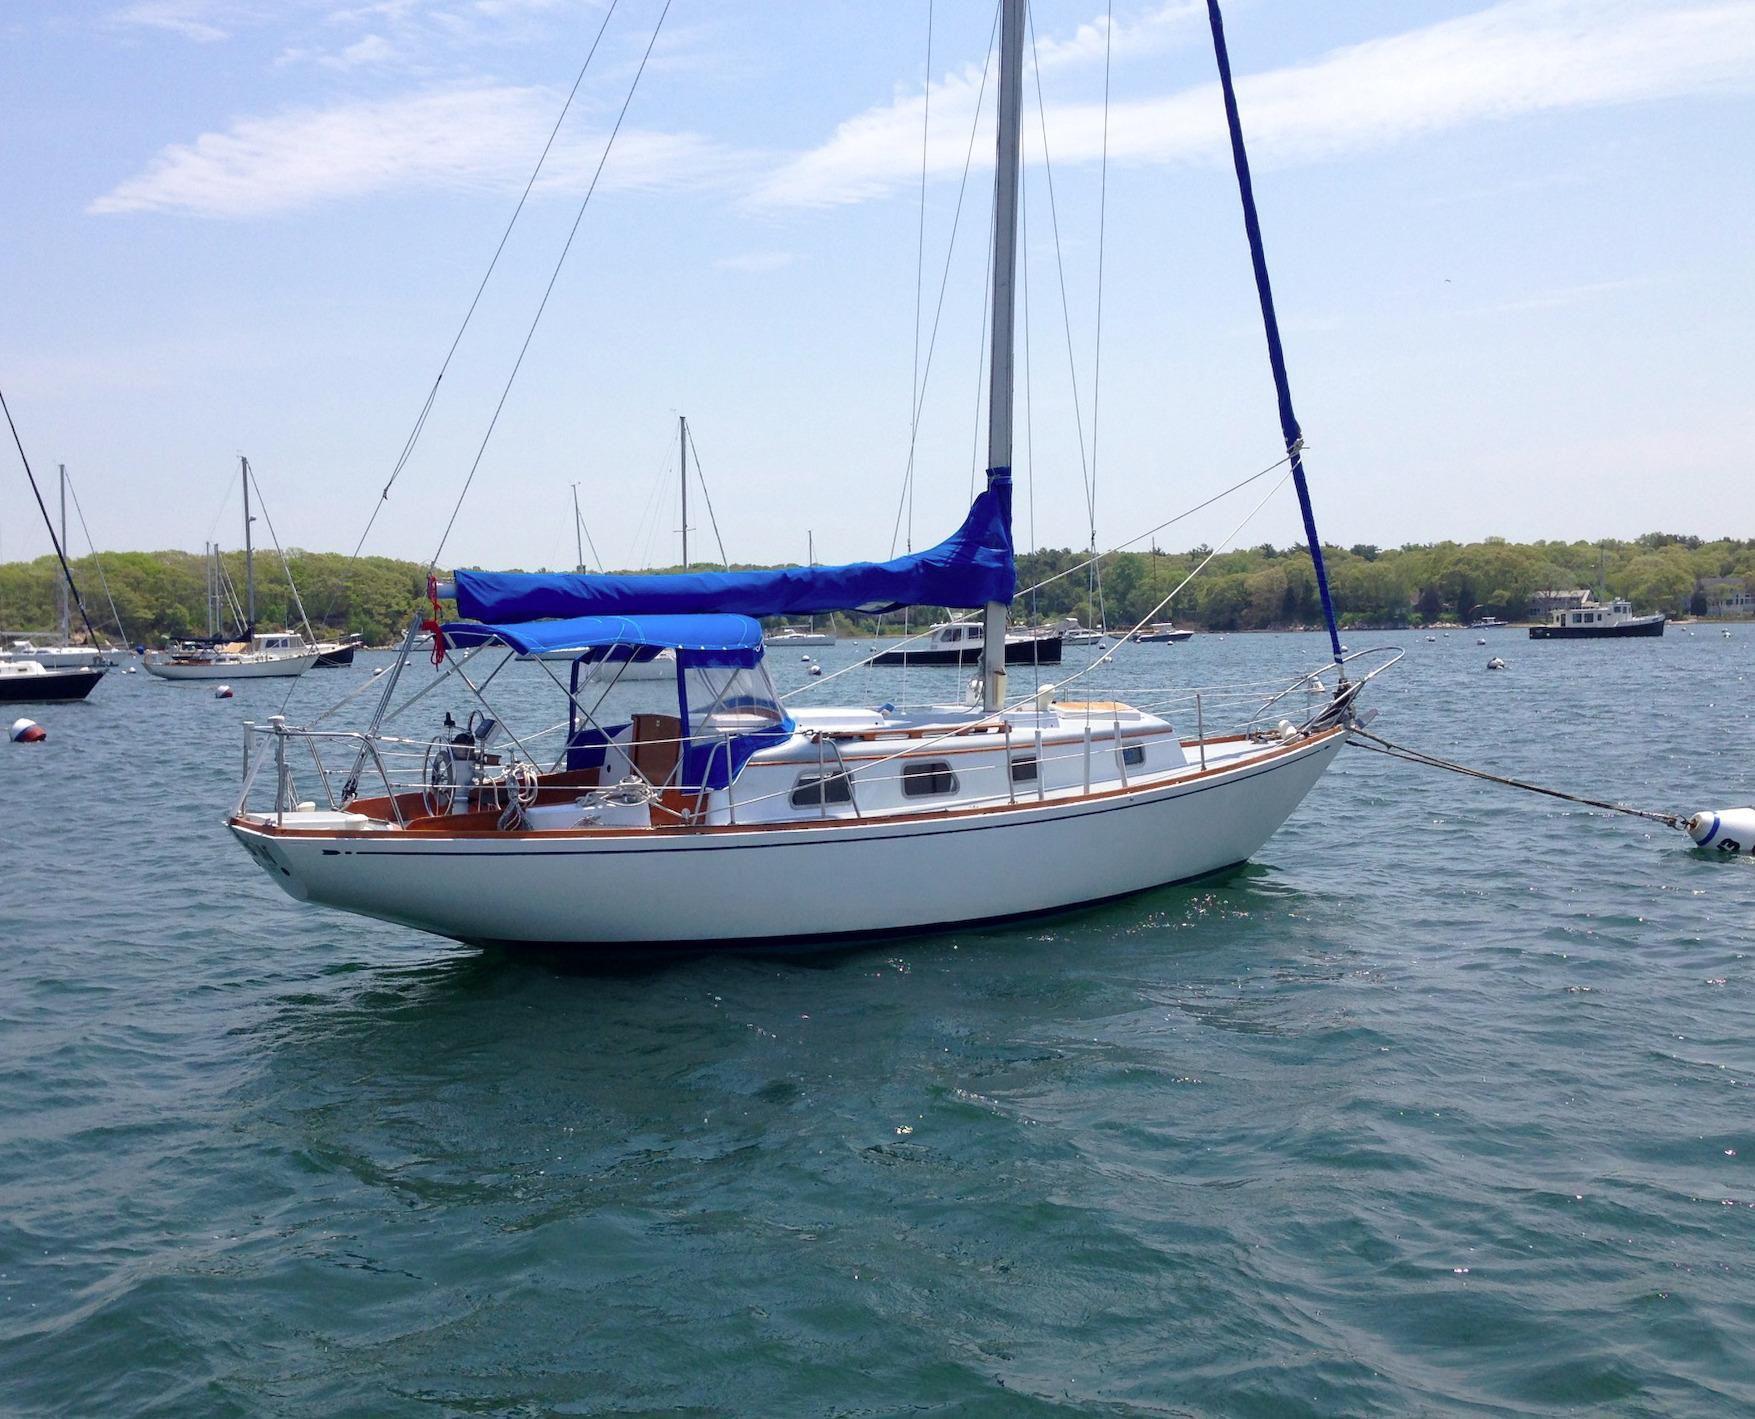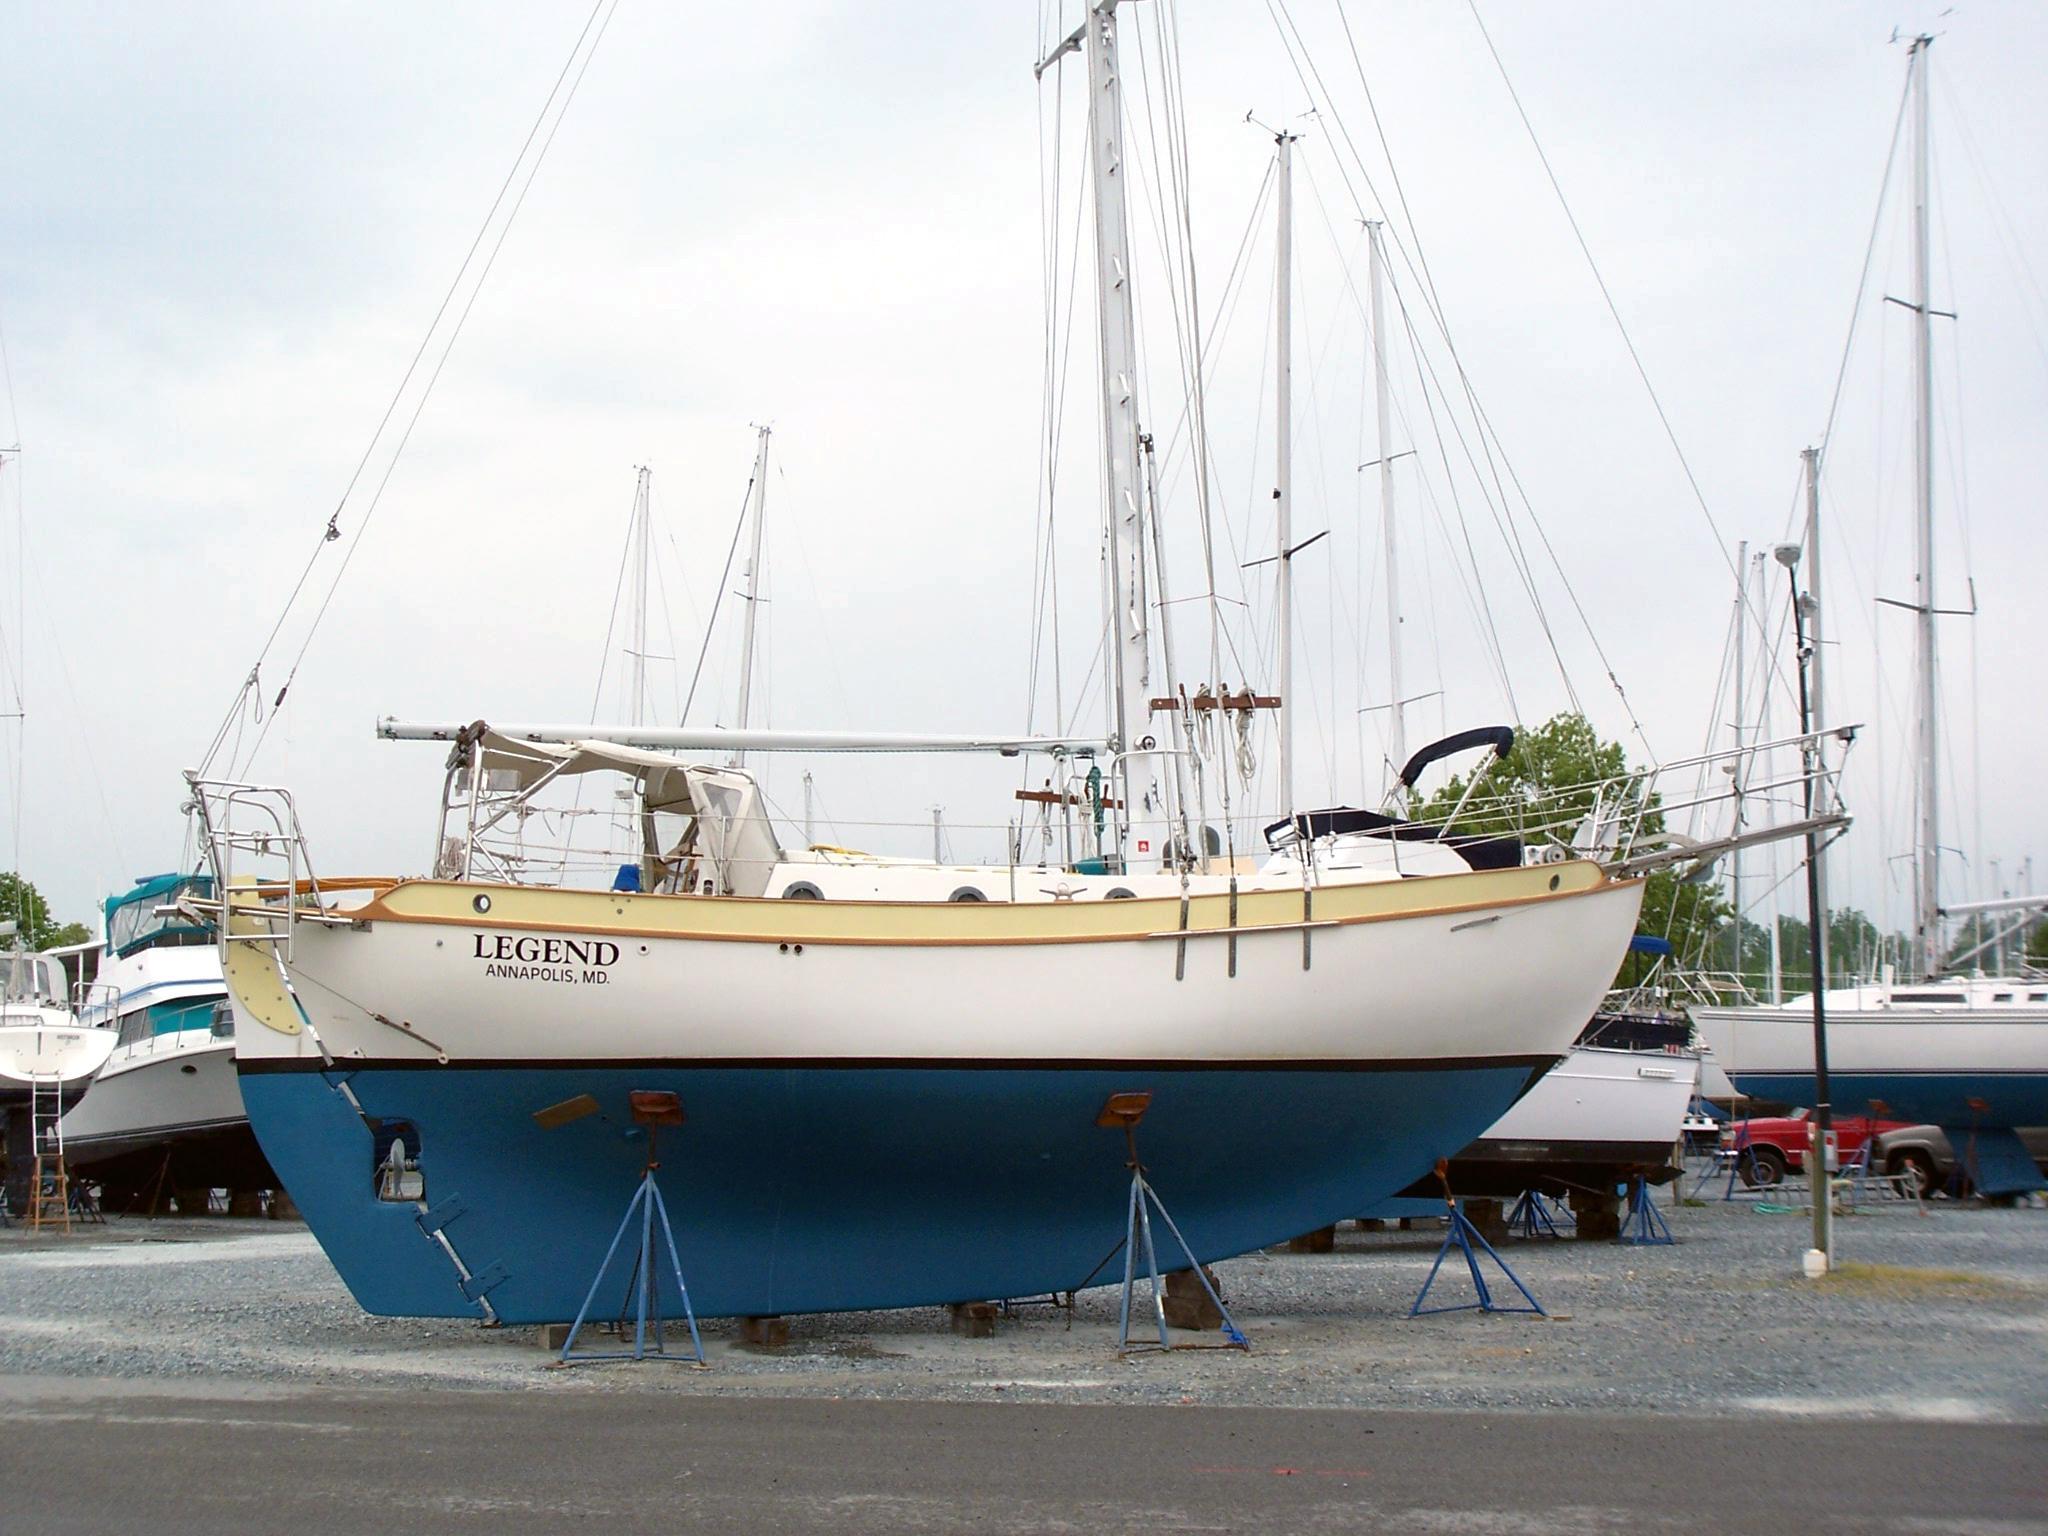The first image is the image on the left, the second image is the image on the right. Considering the images on both sides, is "The sails of at least one boat are furled in tan canvas." valid? Answer yes or no. No. 